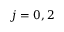Convert formula to latex. <formula><loc_0><loc_0><loc_500><loc_500>j = 0 , 2</formula> 